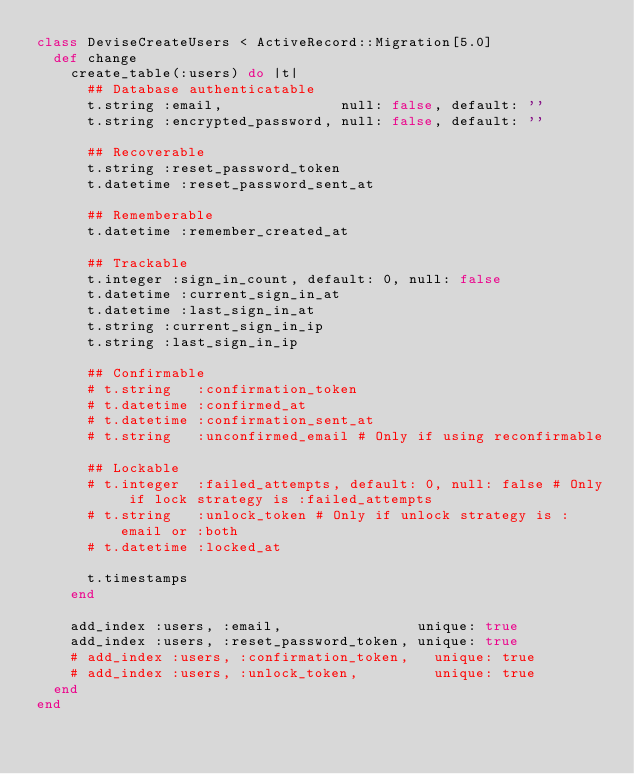Convert code to text. <code><loc_0><loc_0><loc_500><loc_500><_Ruby_>class DeviseCreateUsers < ActiveRecord::Migration[5.0]
  def change
    create_table(:users) do |t|
      ## Database authenticatable
      t.string :email,              null: false, default: ''
      t.string :encrypted_password, null: false, default: ''

      ## Recoverable
      t.string :reset_password_token
      t.datetime :reset_password_sent_at

      ## Rememberable
      t.datetime :remember_created_at

      ## Trackable
      t.integer :sign_in_count, default: 0, null: false
      t.datetime :current_sign_in_at
      t.datetime :last_sign_in_at
      t.string :current_sign_in_ip
      t.string :last_sign_in_ip

      ## Confirmable
      # t.string   :confirmation_token
      # t.datetime :confirmed_at
      # t.datetime :confirmation_sent_at
      # t.string   :unconfirmed_email # Only if using reconfirmable

      ## Lockable
      # t.integer  :failed_attempts, default: 0, null: false # Only if lock strategy is :failed_attempts
      # t.string   :unlock_token # Only if unlock strategy is :email or :both
      # t.datetime :locked_at

      t.timestamps
    end

    add_index :users, :email,                unique: true
    add_index :users, :reset_password_token, unique: true
    # add_index :users, :confirmation_token,   unique: true
    # add_index :users, :unlock_token,         unique: true
  end
end
</code> 